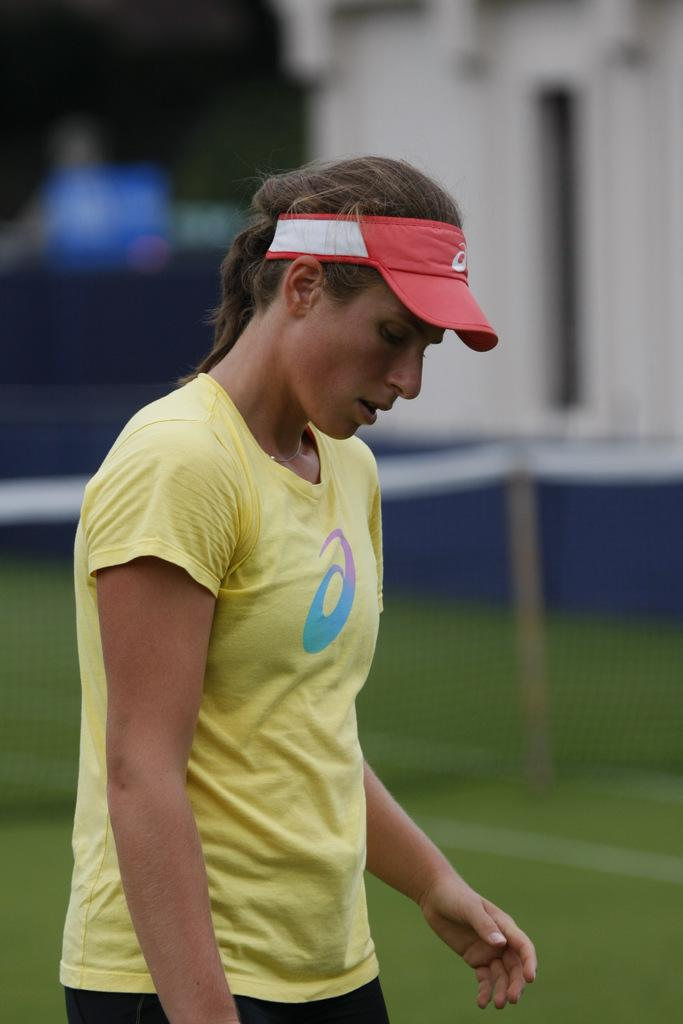Who or what is the main subject in the image? There is a person in the image. What is the person wearing? The person is wearing a yellow t-shirt. What object can be seen in the image besides the person? There is a net visible in the image. Can you describe the background of the image? The background of the image is blurred. What type of food is the person holding in the image? There is no food visible in the image; the person is not holding any food. 